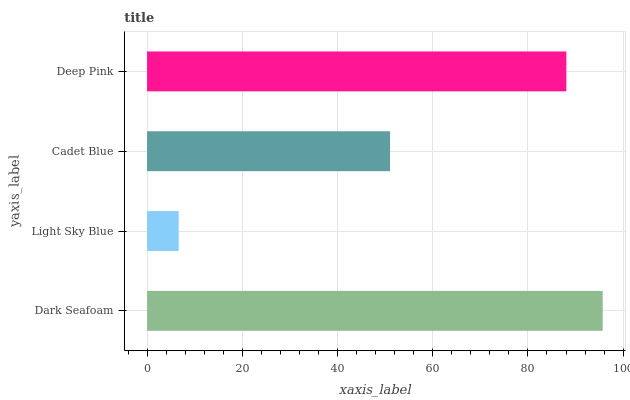Is Light Sky Blue the minimum?
Answer yes or no. Yes. Is Dark Seafoam the maximum?
Answer yes or no. Yes. Is Cadet Blue the minimum?
Answer yes or no. No. Is Cadet Blue the maximum?
Answer yes or no. No. Is Cadet Blue greater than Light Sky Blue?
Answer yes or no. Yes. Is Light Sky Blue less than Cadet Blue?
Answer yes or no. Yes. Is Light Sky Blue greater than Cadet Blue?
Answer yes or no. No. Is Cadet Blue less than Light Sky Blue?
Answer yes or no. No. Is Deep Pink the high median?
Answer yes or no. Yes. Is Cadet Blue the low median?
Answer yes or no. Yes. Is Cadet Blue the high median?
Answer yes or no. No. Is Dark Seafoam the low median?
Answer yes or no. No. 